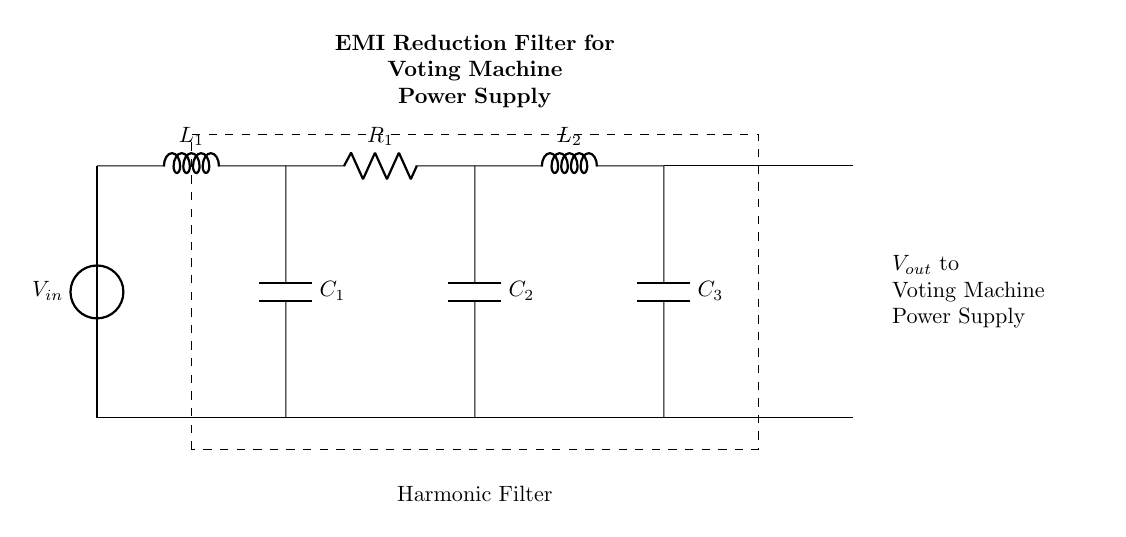What type of filter is shown in the diagram? The diagram depicts a harmonic filter, indicated by the label within the dashed rectangle. It comprises various reactive components designed to reduce electromagnetic interference.
Answer: harmonic filter What is the purpose of this filter? The purpose of this EMI reduction filter is to manage and minimize electromagnetic interference that could affect the operation of the voting machine power supply, ensuring reliable performance.
Answer: EMI reduction How many capacitors are present in the circuit? There are three capacitors present in the circuit, labeled C1, C2, and C3, which are connected in a configuration intended for filtering purposes.
Answer: three What components are shown in series with the voltage source? The components in series with the voltage source include an inductor L1 and a resistor R1, both of which are critical for filtering out unwanted harmonic frequencies.
Answer: inductor and resistor Which component directly supplies the output to the voting machine? The output comes from the point where voltage connects to the voting machine power supply, which includes contributions from capacitors and inductors mentioned in the circuit.
Answer: voltage from capacitors How many inductors are present in the circuit? The circuit has two inductors indicated by L1 and L2, which play a role in the filtering process by helping to attenuate high-frequency noise.
Answer: two What is the output voltage labeled as? The output voltage is labeled Vout, which connects to the voting machine power supply, showing where the filtered voltage is delivered.
Answer: Vout 